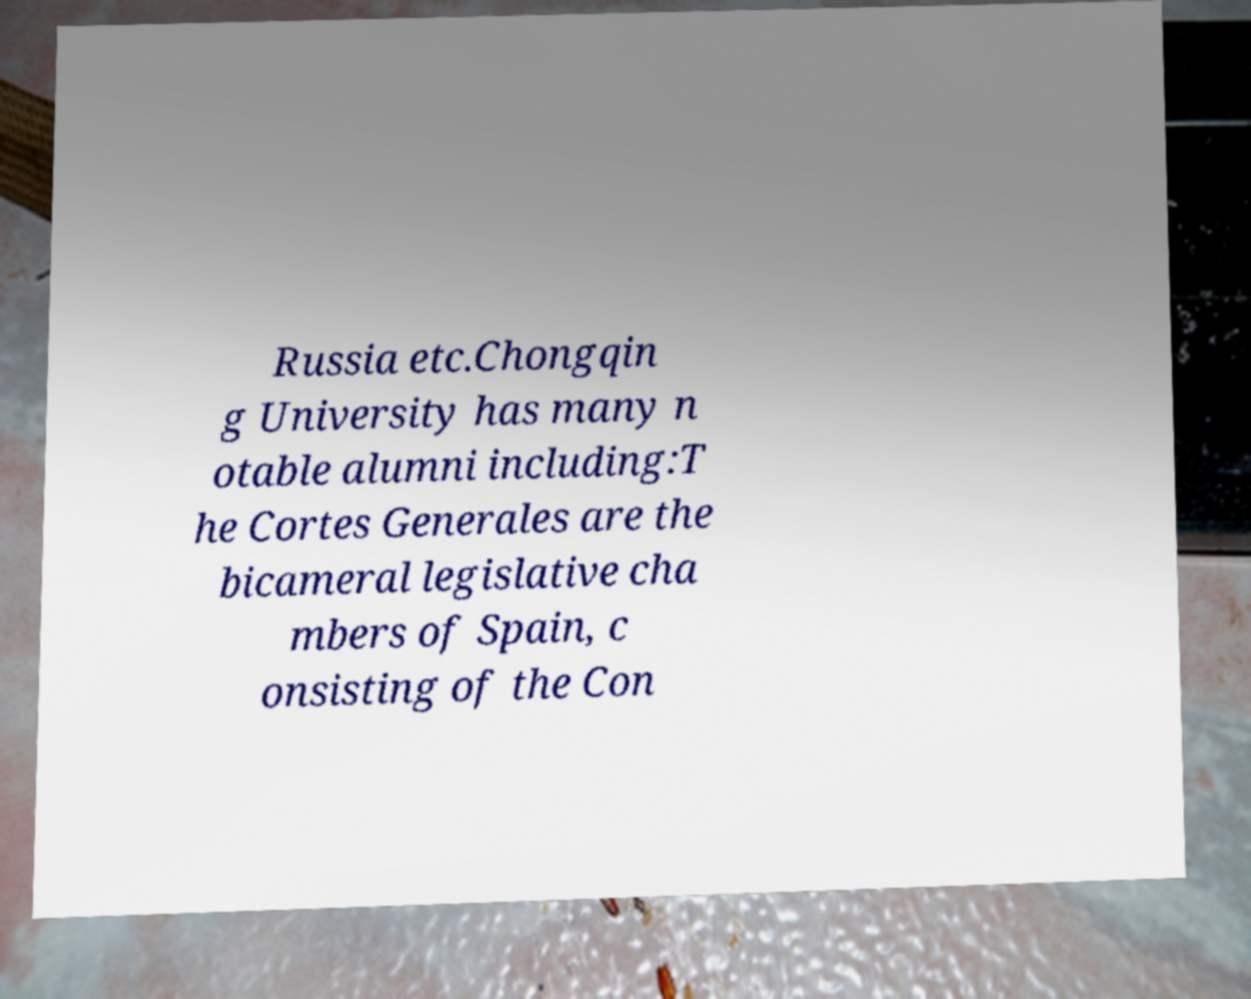Please identify and transcribe the text found in this image. Russia etc.Chongqin g University has many n otable alumni including:T he Cortes Generales are the bicameral legislative cha mbers of Spain, c onsisting of the Con 